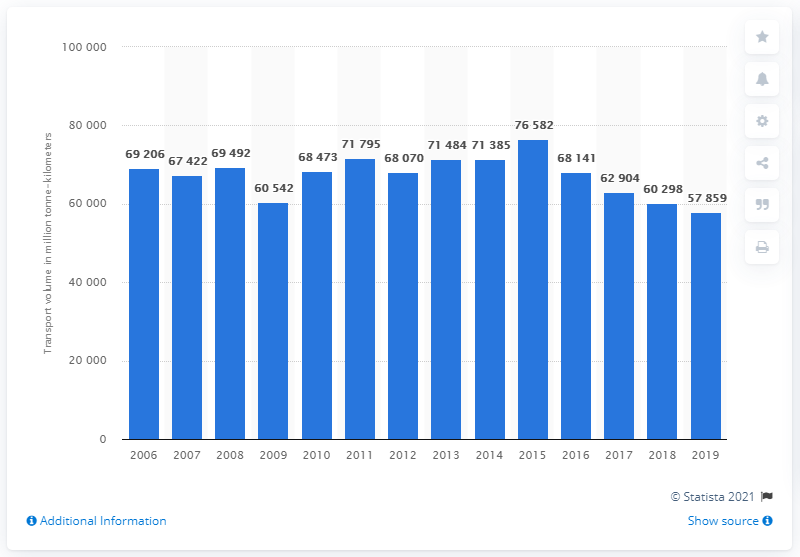Outline some significant characteristics in this image. In the time period of 2006 to 2019, a total of 57,859 metric tons of freight was transported in Czechia. 